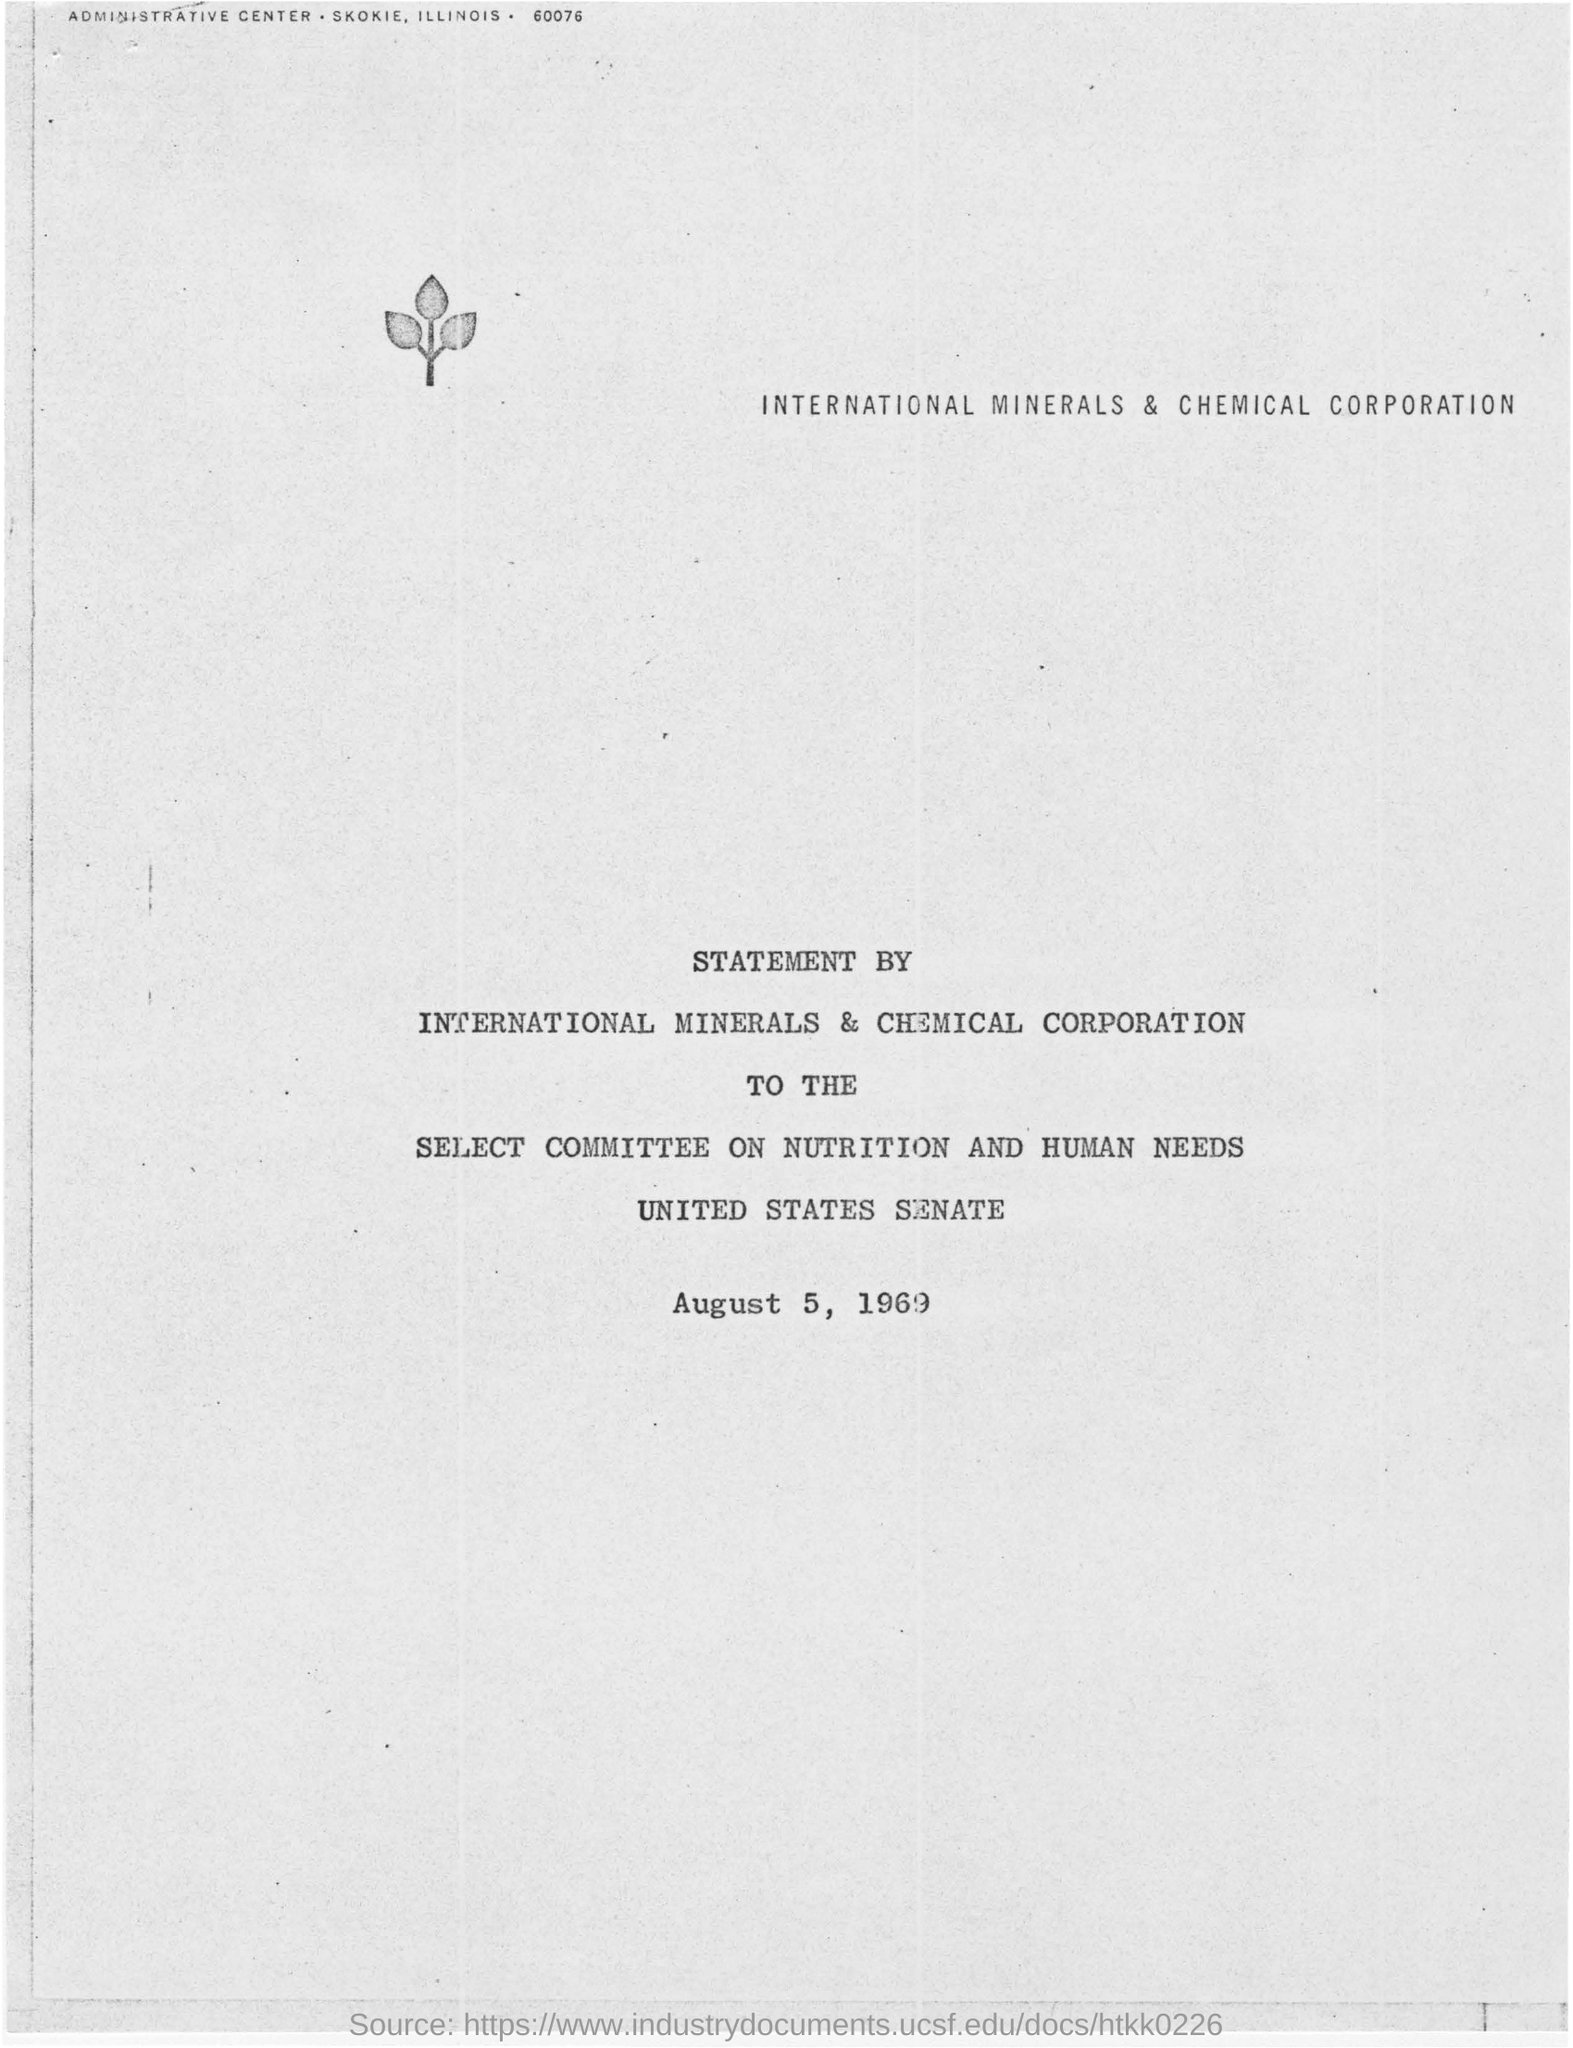Who gave the statement?
Your response must be concise. INTERNATIONAL MINERALS & CHEMICAL CORPORATION. On which date statement was issued?
Give a very brief answer. August 5 1969. 